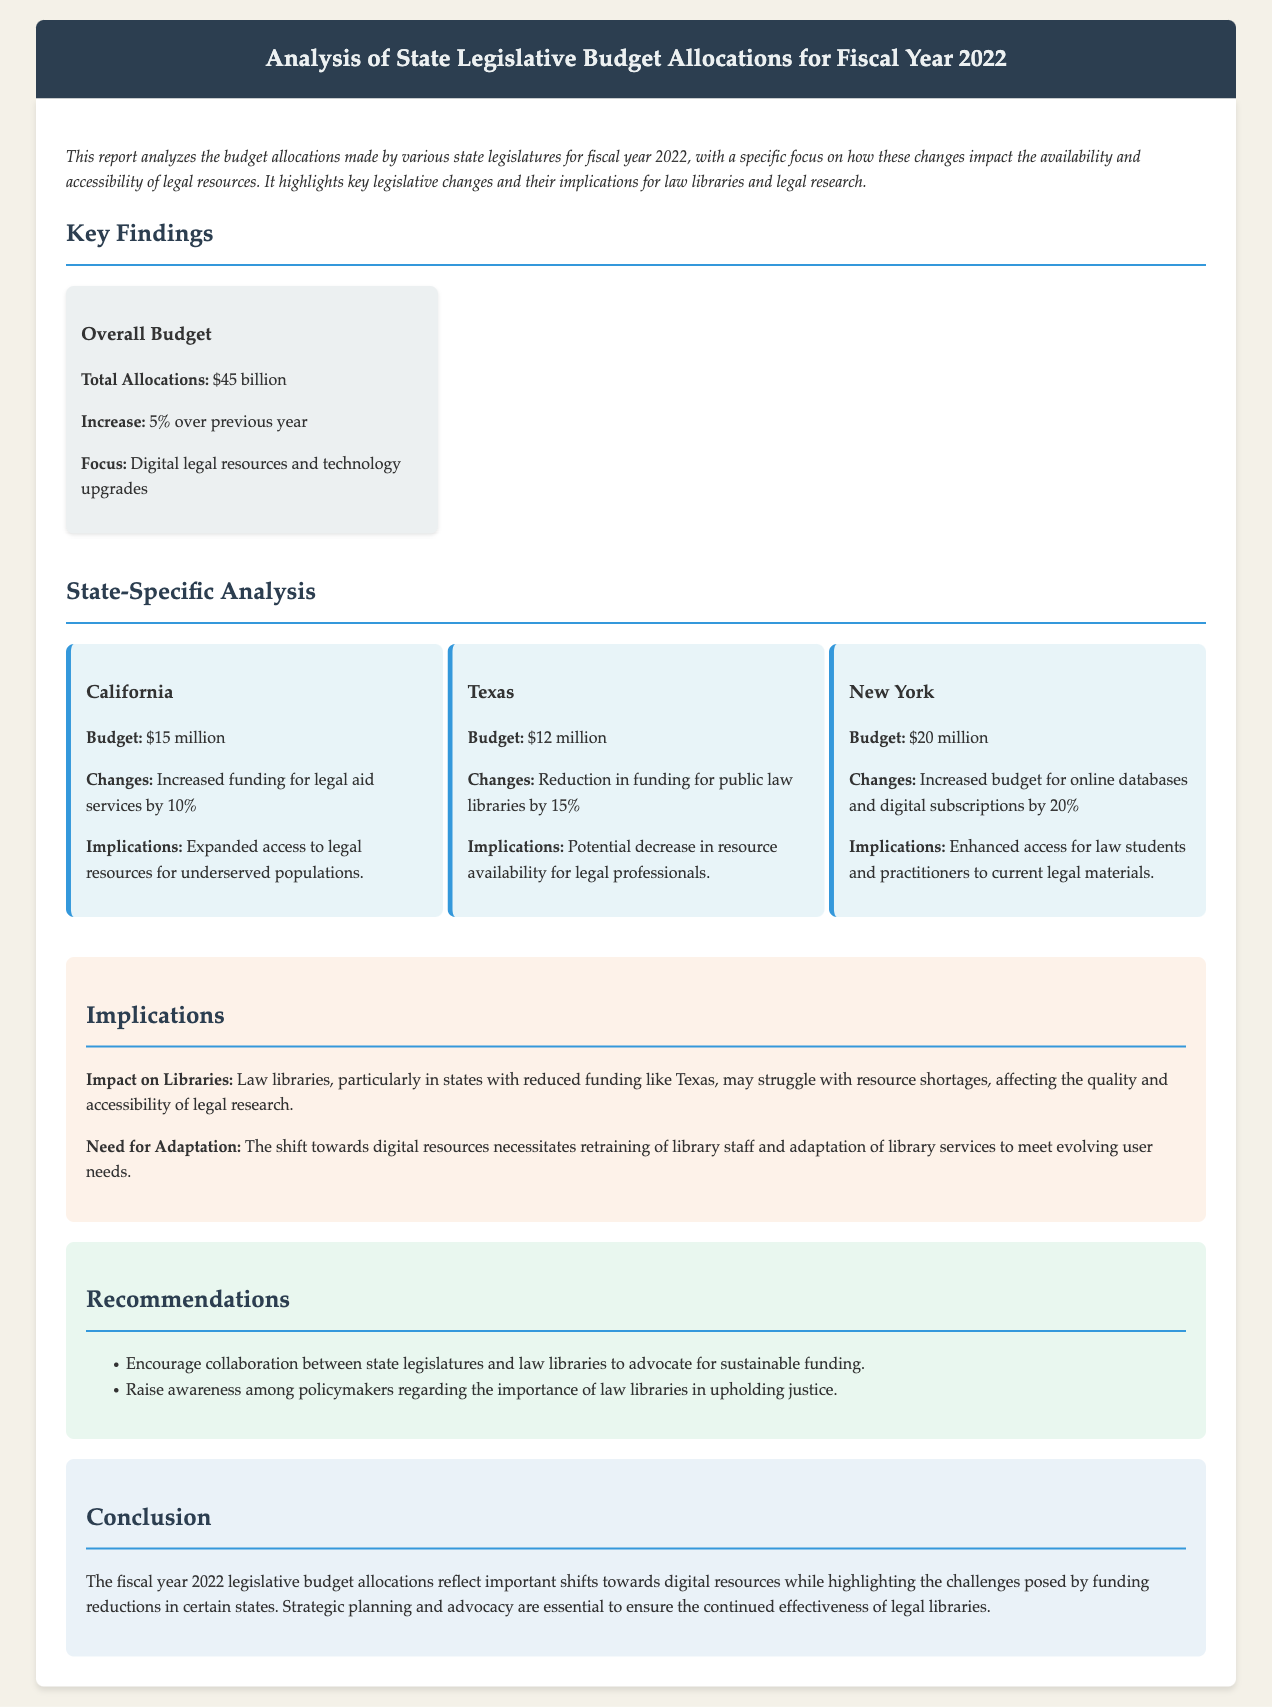What is the total allocation for fiscal year 2022? The total allocation is stated directly in the document as $45 billion.
Answer: $45 billion What was the percentage increase over the previous year? The document mentions that the increase in budget allocations was 5% over the previous year.
Answer: 5% Which state saw a 10% increase in funding for legal aid services? The document specifies that California experienced a 10% increase in funding for legal aid services.
Answer: California What change occurred in Texas' funding for public law libraries? The report states that Texas experienced a reduction in funding for public law libraries by 15%.
Answer: Reduction by 15% How much did New York increase its budget for online databases? The document indicates that New York increased its budget for online databases and digital subscriptions by 20%.
Answer: 20% What is one implication of reduced funding for law libraries mentioned in the document? The document discusses that reduced funding can lead to resource shortages, affecting the quality and accessibility of legal research.
Answer: Resource shortages What does the report suggest for state legislatures regarding law libraries? The report recommends that state legislatures should collaborate with law libraries to advocate for sustainable funding.
Answer: Advocate for sustainable funding What was a key focus of the overall budget allocation? The document highlights that the focus of the overall budget allocation was on digital legal resources and technology upgrades.
Answer: Digital legal resources and technology upgrades What is a recommendation made in the report concerning policymakers? One recommendation is to raise awareness among policymakers regarding the importance of law libraries in upholding justice.
Answer: Raise awareness among policymakers 